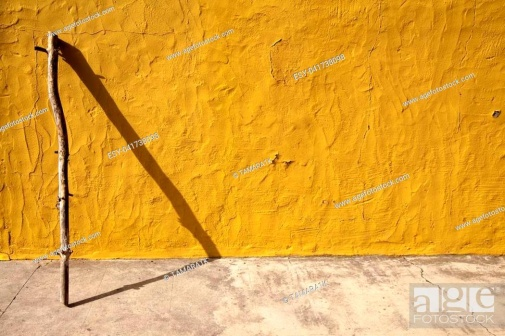How do you think the lighting in this scene was achieved? The distinct shadow cast by the stick suggests that the lighting in this scene is achieved through a strong and directional light source, likely the sun, positioned at an angle that creates this elongated silhouette. The vibrant illumination of the yellow wall indicates that the light source is bright and unobstructed, ensuring the shadow is sharp and well-defined against the backdrop. Could this image symbolize something deeper or metaphorical? Absolutely, this image can be rich with metaphorical significance. The stick could symbolize life’s journey, standing tall against the vibrant wall which represents the canvas of experiences and memories. The shadow might signify the impact or legacy left behind, illustrating how our actions and presence cast ripples even when we are no longer there. This interplay of light and shadow could reflect on themes of existence, time, and the enduring nature of one’s imprint on the world. 